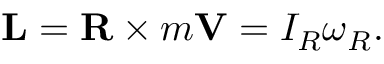Convert formula to latex. <formula><loc_0><loc_0><loc_500><loc_500>L = R \times m V = I _ { R } { \omega } _ { R } .</formula> 